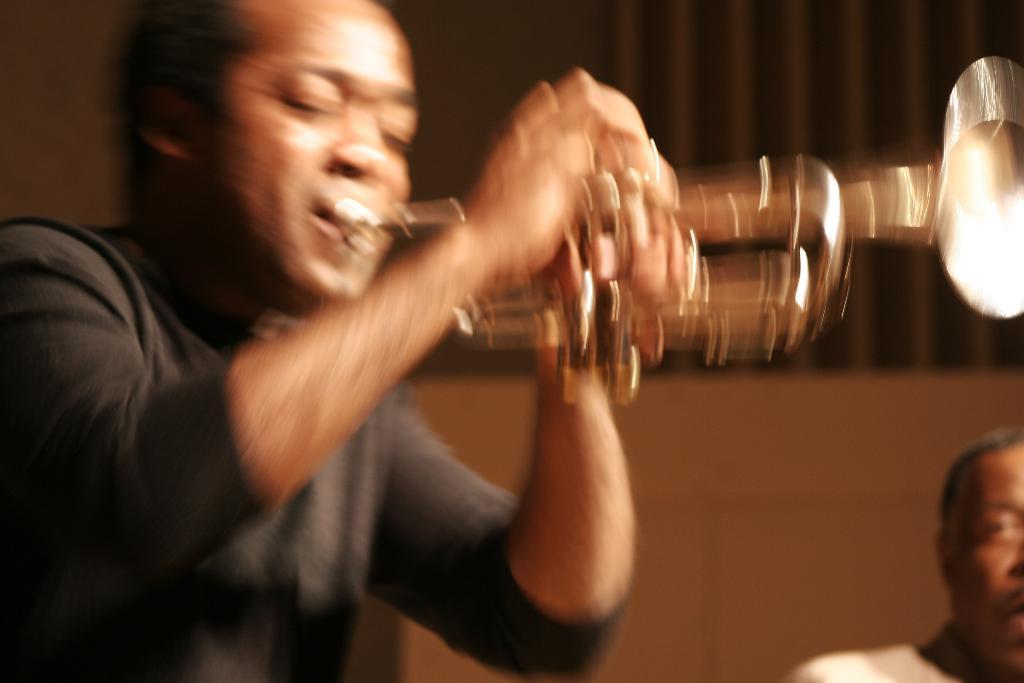What is the man in the image doing? The man in the image is playing a trumpet. Can you describe the person behind the man playing the trumpet? There is an old man behind the man playing the trumpet. How many dolls are sitting on the dirt in the image? There are no dolls or dirt present in the image. Is the man wearing a mask while playing the trumpet in the image? There is no mention of a mask in the image, and the man is playing the trumpet without one. 